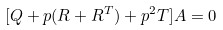Convert formula to latex. <formula><loc_0><loc_0><loc_500><loc_500>[ Q + p ( R + R ^ { T } ) + p ^ { 2 } T ] A = 0</formula> 